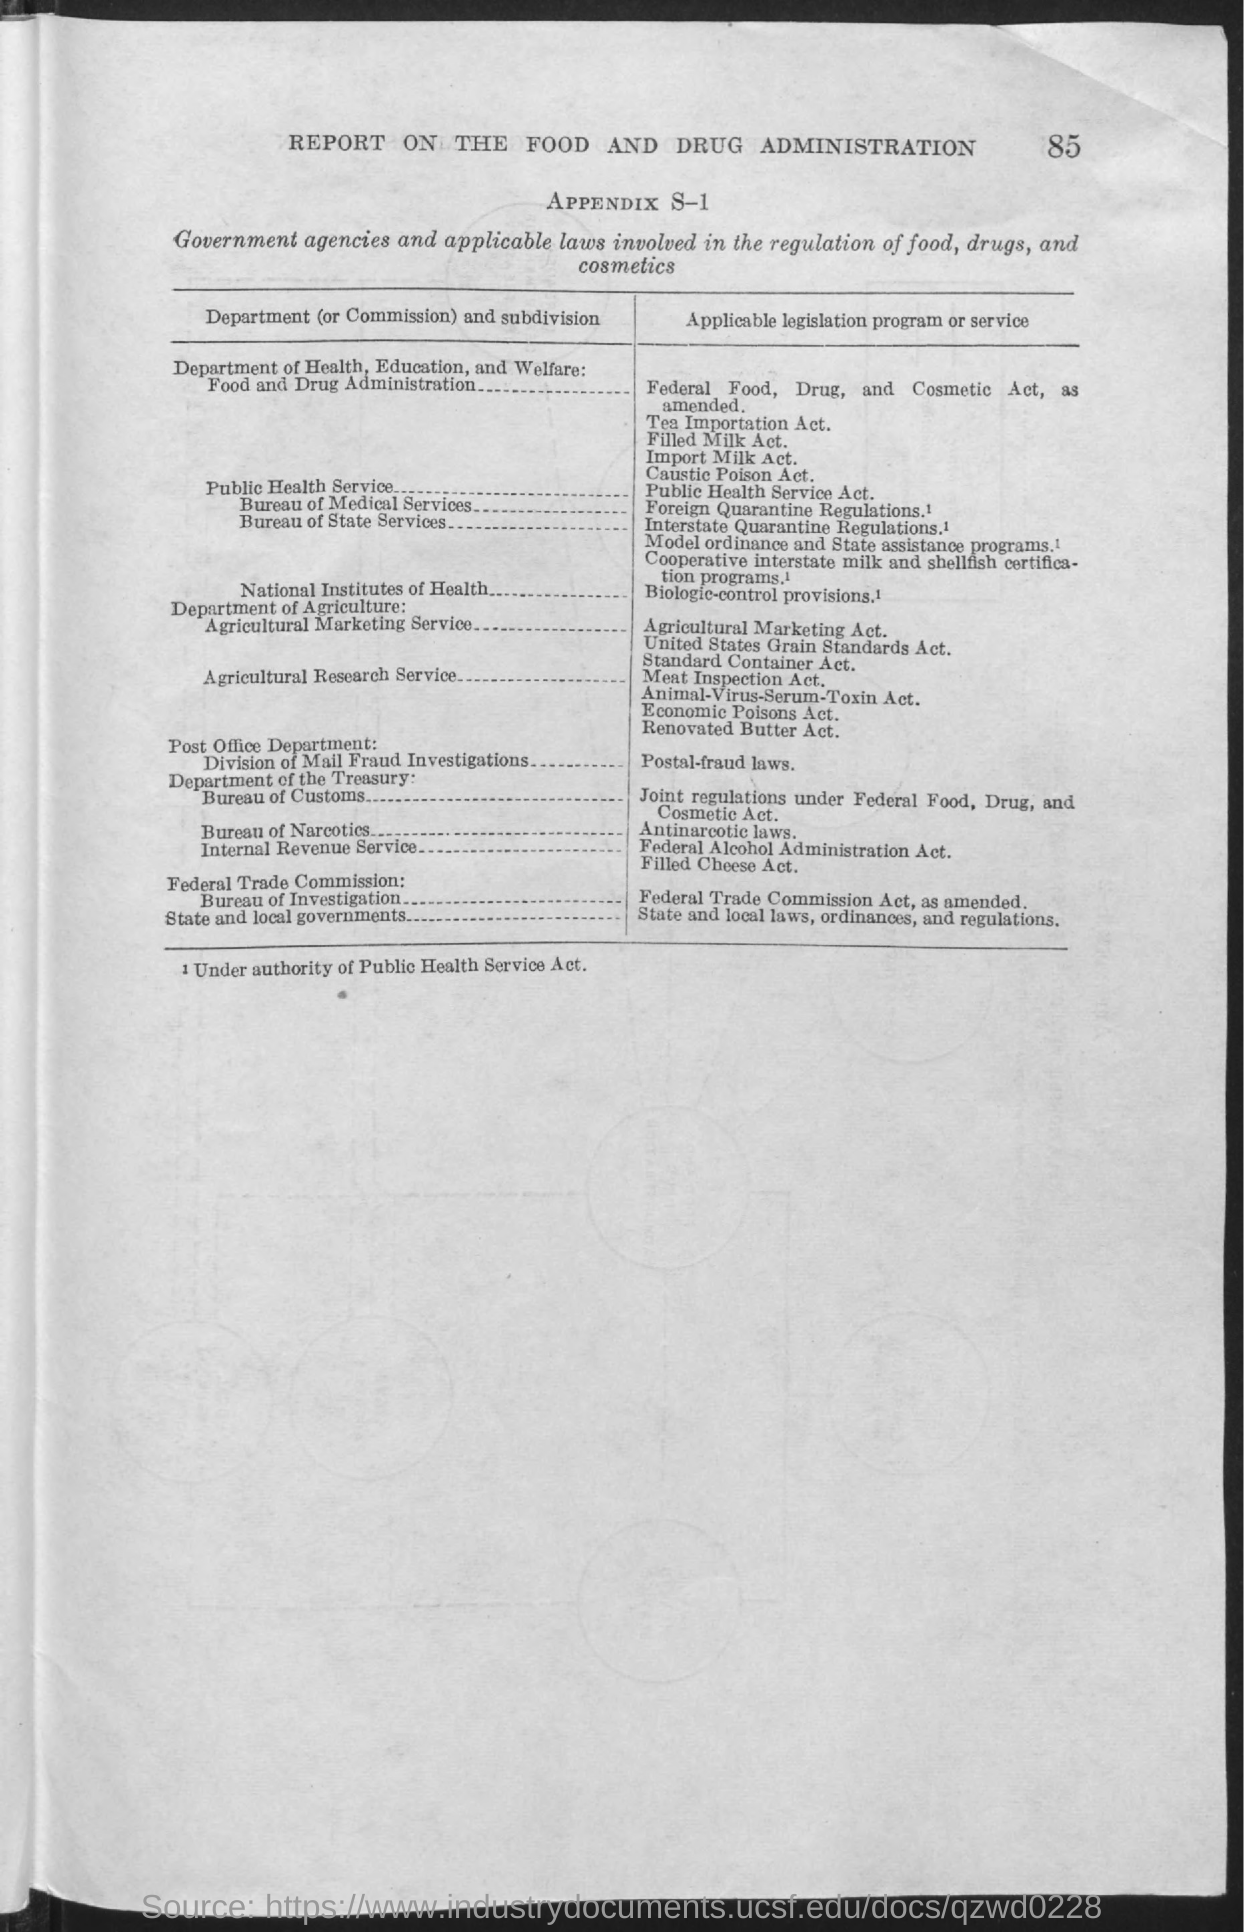What is the page number at top of the page?
Give a very brief answer. 85. What is the title of the report?
Offer a very short reply. Report on the Food and Drug Administration. 